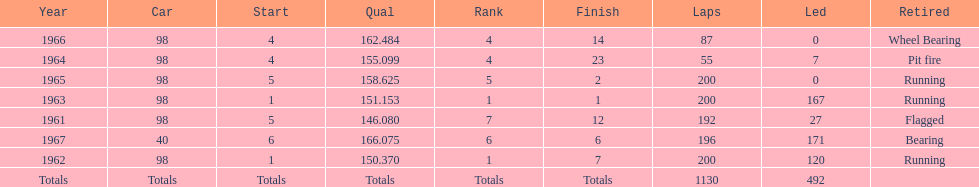For how many successive years did parnelli rank in the top 5? 5. 